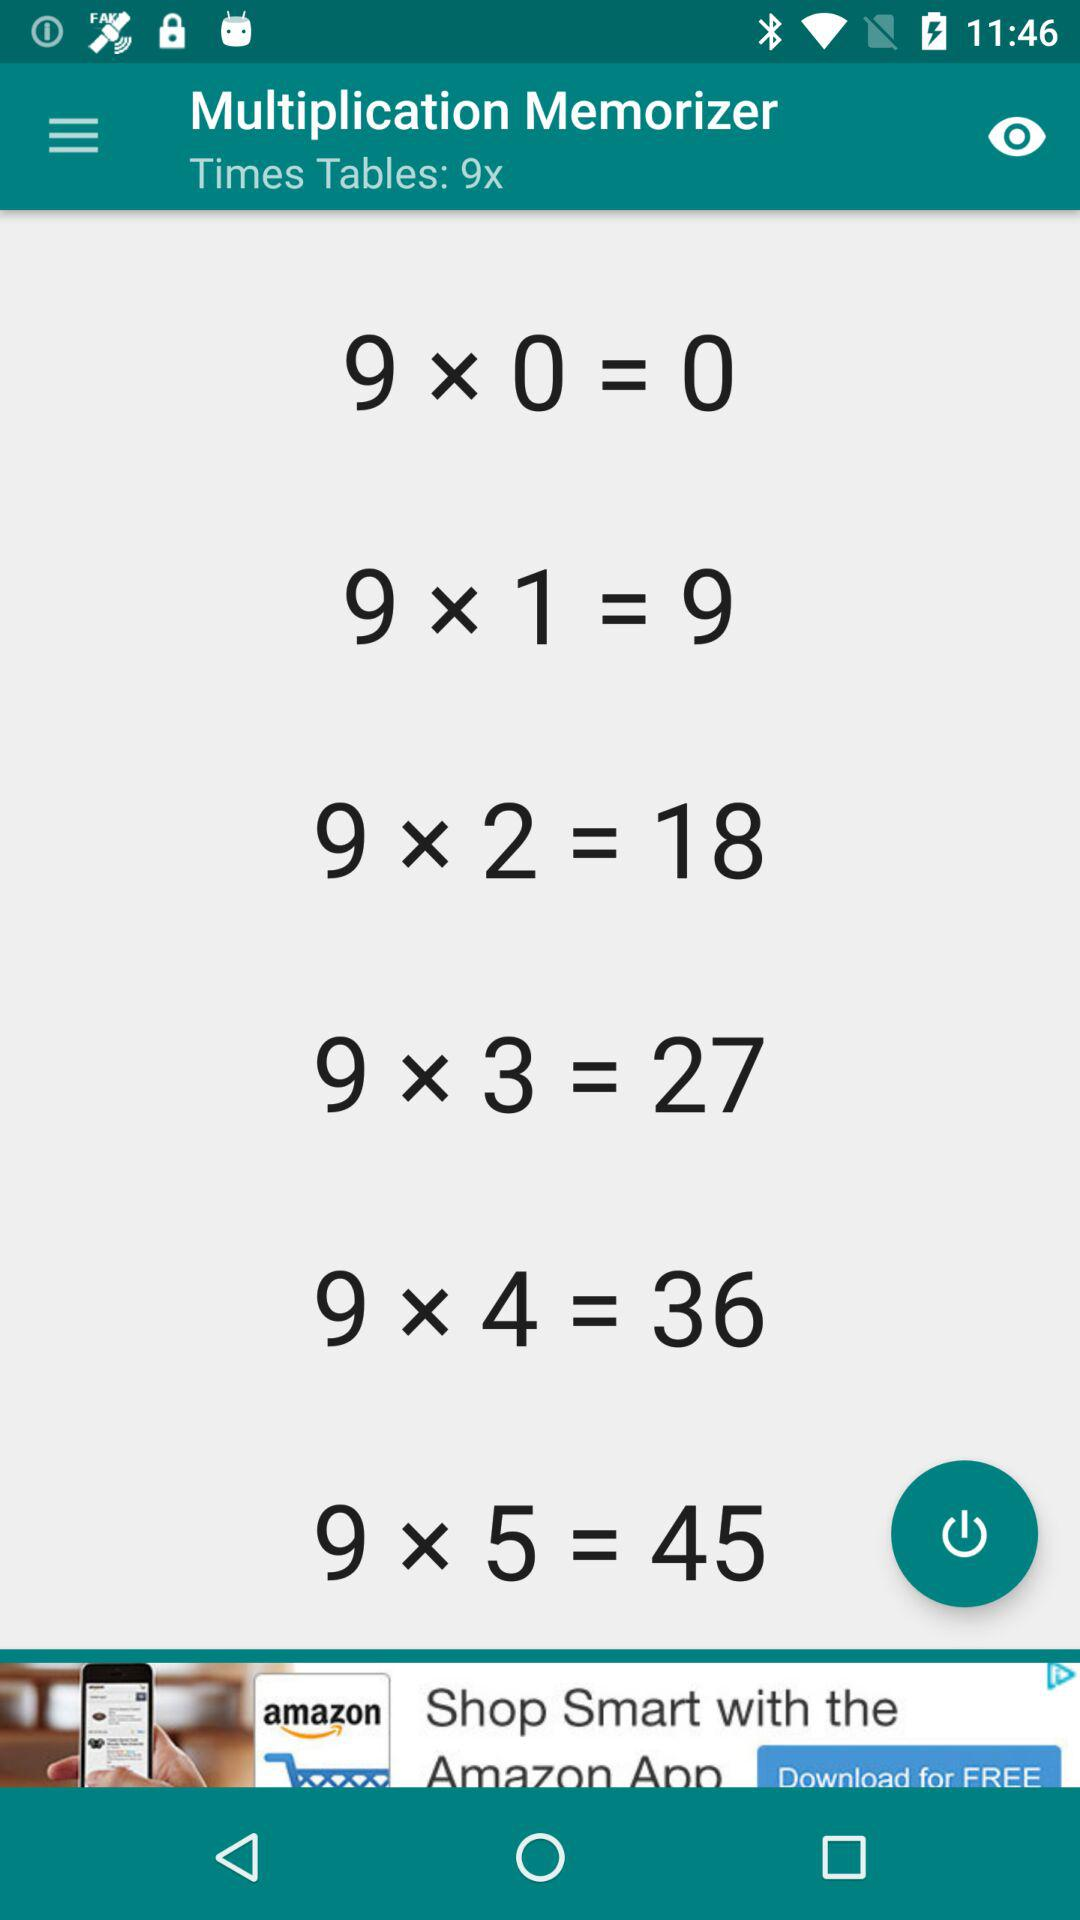How many multiples of 9 are there on this screen?
Answer the question using a single word or phrase. 6 